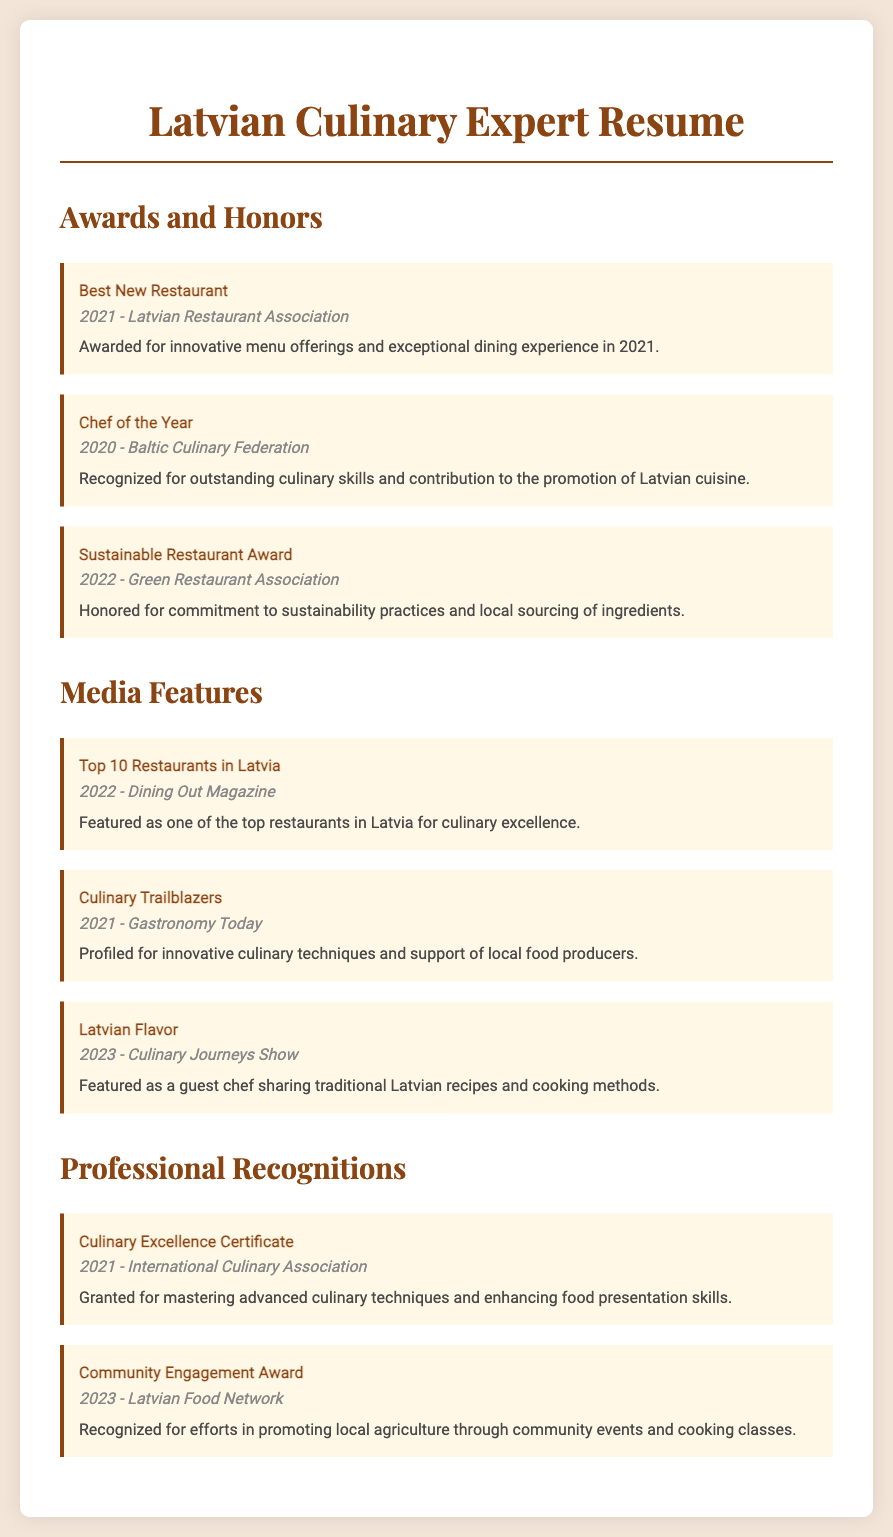What award did the Latvian Restaurant Association give in 2021? The award given by the Latvian Restaurant Association in 2021 was for Best New Restaurant.
Answer: Best New Restaurant Who was recognized as Chef of the Year in 2020? The title of Chef of the Year in 2020 was awarded by the Baltic Culinary Federation.
Answer: Chef of the Year What notable media feature was published in 2022? In 2022, Dining Out Magazine featured a list of top restaurants which included this restaurant.
Answer: Top 10 Restaurants in Latvia Which award was received for sustainability practices? The Sustainable Restaurant Award was awarded for commitment to sustainability practices.
Answer: Sustainable Restaurant Award What year was the Culinary Excellence Certificate granted? The Culinary Excellence Certificate was granted in 2021.
Answer: 2021 Identify a media feature highlighting traditional Latvian recipes. The feature that highlighted traditional Latvian recipes was titled Latvian Flavor.
Answer: Latvian Flavor What is one of the recognitions received related to community engagement? The Community Engagement Award was given for promoting local agriculture.
Answer: Community Engagement Award How many awards were mentioned in the document? The document mentions three awards under the Awards and Honors section.
Answer: Three What organization awarded the Sustainable Restaurant Award? The organization that awarded the Sustainable Restaurant Award is the Green Restaurant Association.
Answer: Green Restaurant Association 